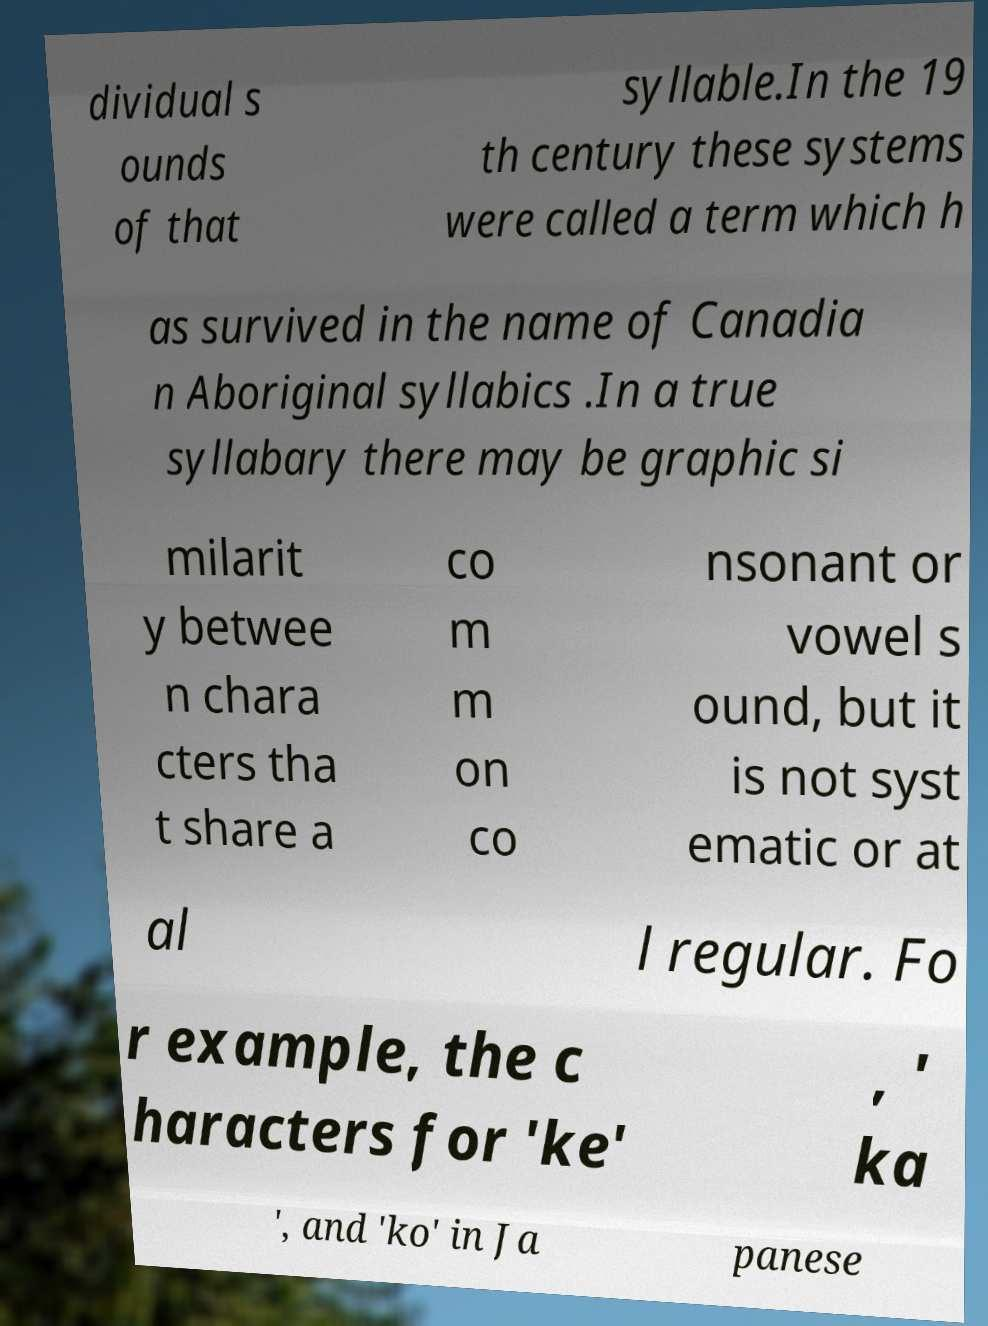For documentation purposes, I need the text within this image transcribed. Could you provide that? dividual s ounds of that syllable.In the 19 th century these systems were called a term which h as survived in the name of Canadia n Aboriginal syllabics .In a true syllabary there may be graphic si milarit y betwee n chara cters tha t share a co m m on co nsonant or vowel s ound, but it is not syst ematic or at al l regular. Fo r example, the c haracters for 'ke' , ' ka ', and 'ko' in Ja panese 